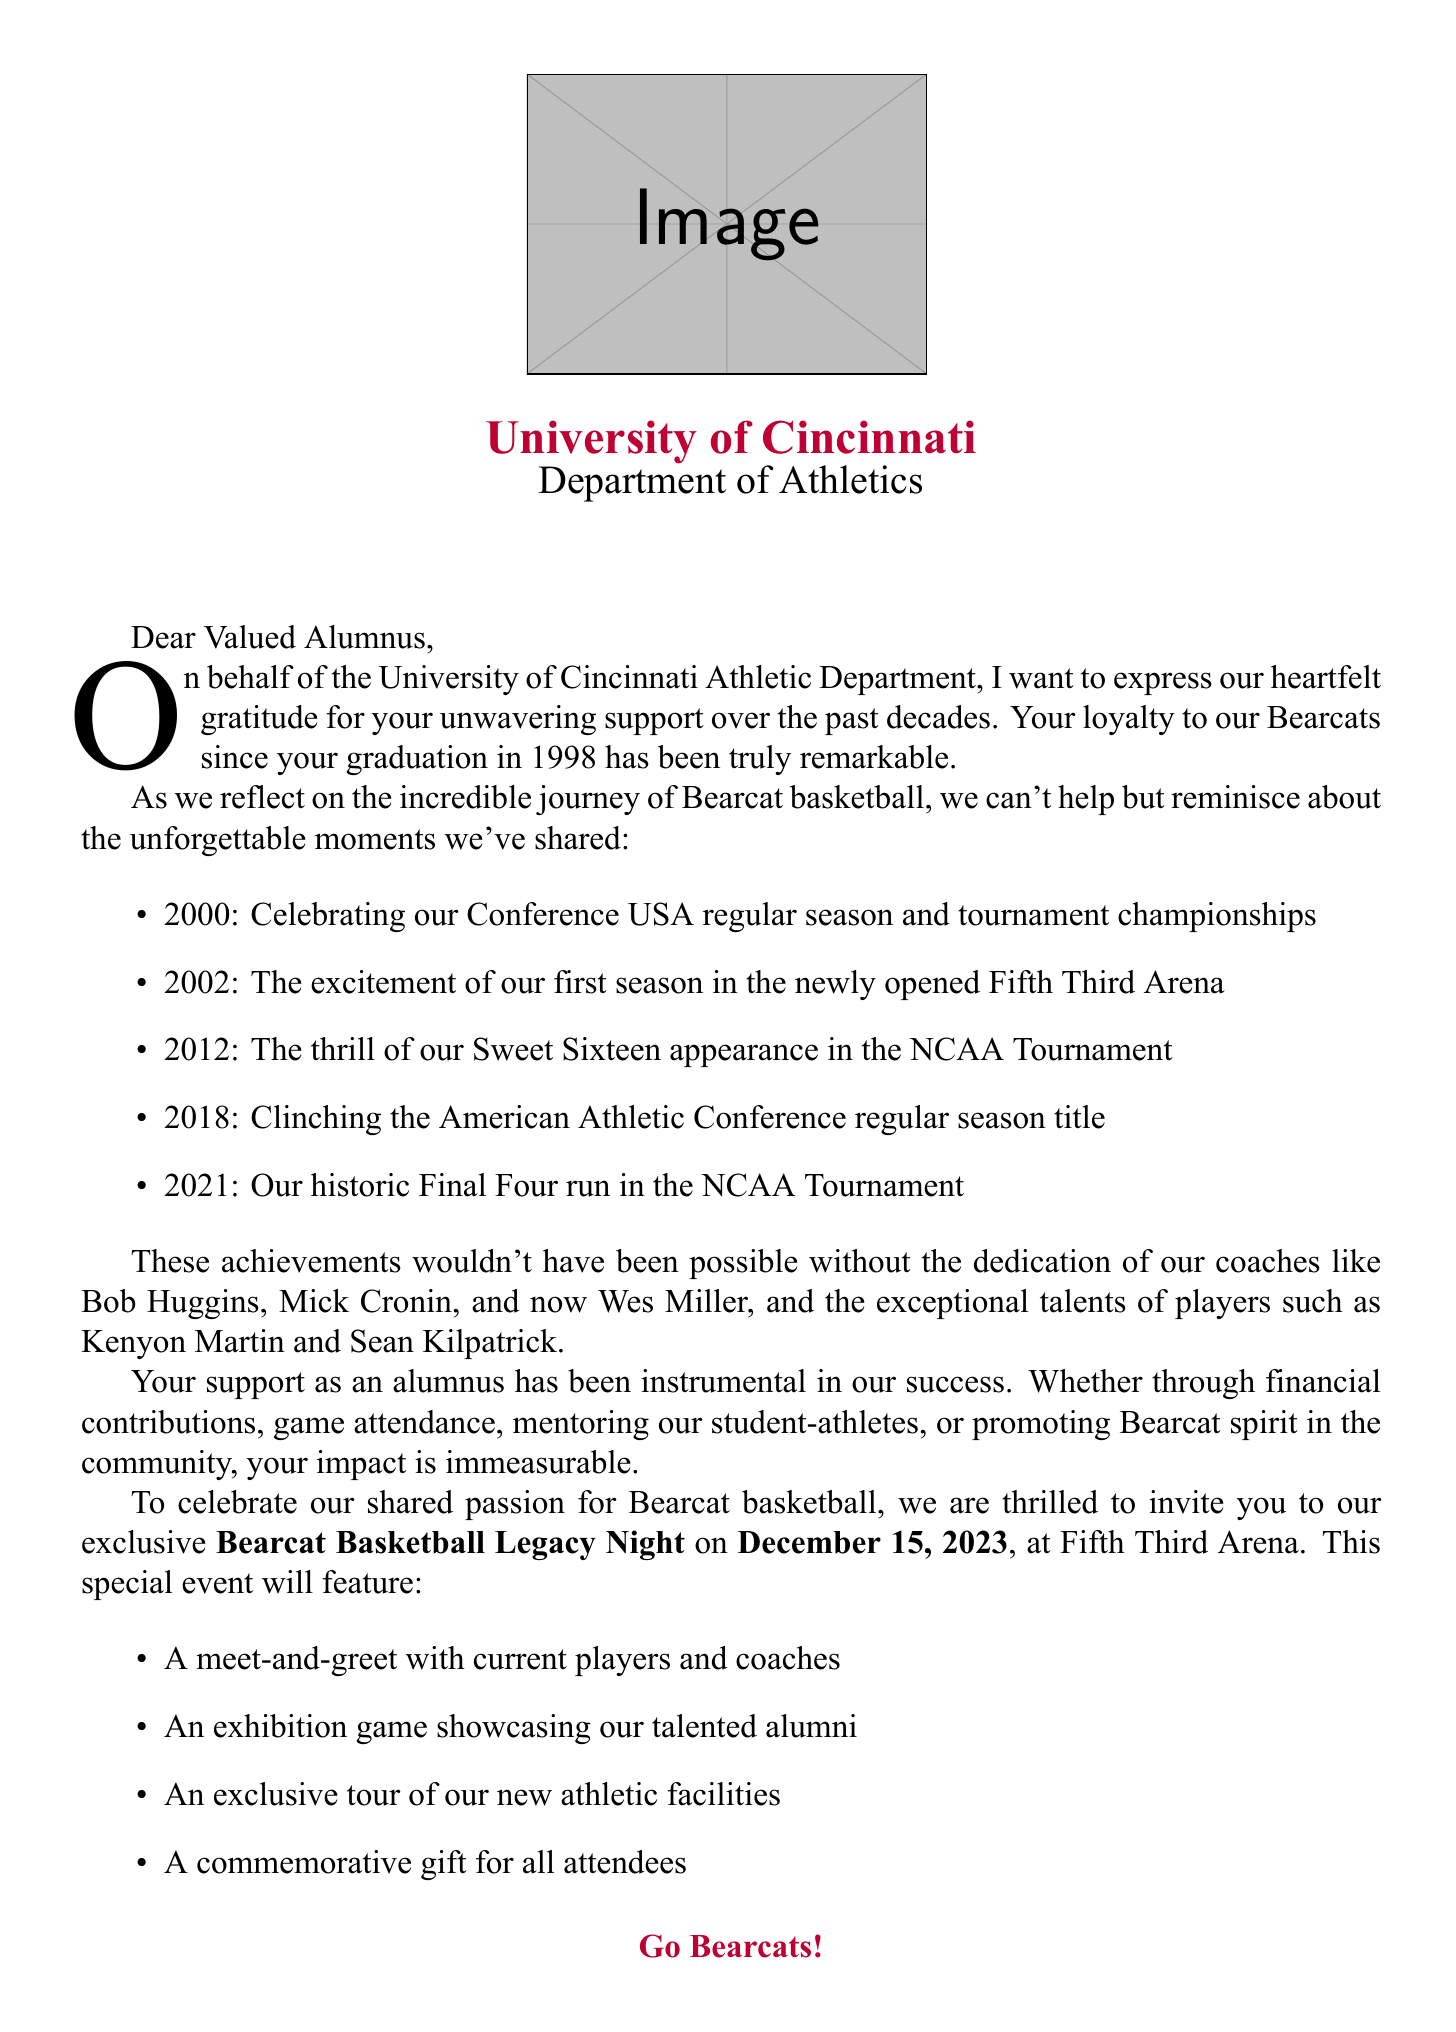What is the name of the special event? The special event mentioned in the letter is called Bearcat Basketball Legacy Night.
Answer: Bearcat Basketball Legacy Night What is the date of the event? The letter states that the event will take place on December 15, 2023.
Answer: December 15, 2023 Who is the current head coach? The letter names Wes Miller as the current head coach (2021-present).
Answer: Wes Miller Which conference did the Bearcats join in 2023? The letter indicates that the Bearcats joined the Big 12 Conference in 2023.
Answer: Big 12 Conference What notable achievement happened in 2002? The letter recalls the first season in Fifth Third Arena as a memorable moment from 2002.
Answer: First season in Fifth Third Arena How many activities will there be at the special event? The letter lists four activities that will take place at the Bearcat Basketball Legacy Night.
Answer: Four What role did Kenyon Martin have? In the letter, Kenyon Martin is referred to as a star player (1996-2000).
Answer: Star Player What impact does alumni support have according to the letter? The letter highlights that alumni support provides financial support for scholarships among other contributions.
Answer: Financial support for scholarships Who expressed gratitude in the letter? The gratitude in the letter is expressed by John Cunningham, the Director of Athletics.
Answer: John Cunningham 